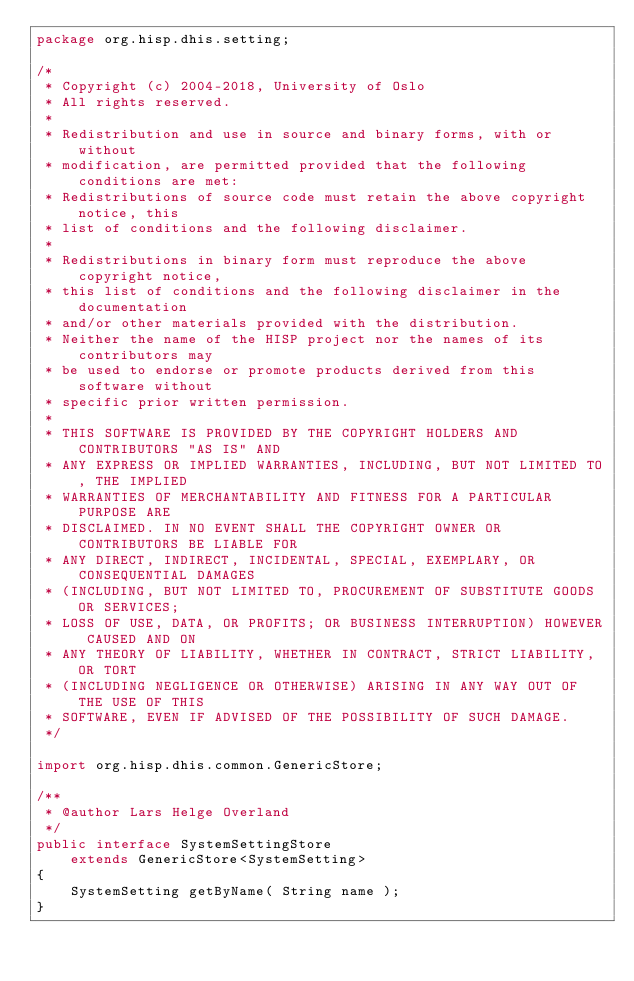<code> <loc_0><loc_0><loc_500><loc_500><_Java_>package org.hisp.dhis.setting;

/*
 * Copyright (c) 2004-2018, University of Oslo
 * All rights reserved.
 *
 * Redistribution and use in source and binary forms, with or without
 * modification, are permitted provided that the following conditions are met:
 * Redistributions of source code must retain the above copyright notice, this
 * list of conditions and the following disclaimer.
 *
 * Redistributions in binary form must reproduce the above copyright notice,
 * this list of conditions and the following disclaimer in the documentation
 * and/or other materials provided with the distribution.
 * Neither the name of the HISP project nor the names of its contributors may
 * be used to endorse or promote products derived from this software without
 * specific prior written permission.
 *
 * THIS SOFTWARE IS PROVIDED BY THE COPYRIGHT HOLDERS AND CONTRIBUTORS "AS IS" AND
 * ANY EXPRESS OR IMPLIED WARRANTIES, INCLUDING, BUT NOT LIMITED TO, THE IMPLIED
 * WARRANTIES OF MERCHANTABILITY AND FITNESS FOR A PARTICULAR PURPOSE ARE
 * DISCLAIMED. IN NO EVENT SHALL THE COPYRIGHT OWNER OR CONTRIBUTORS BE LIABLE FOR
 * ANY DIRECT, INDIRECT, INCIDENTAL, SPECIAL, EXEMPLARY, OR CONSEQUENTIAL DAMAGES
 * (INCLUDING, BUT NOT LIMITED TO, PROCUREMENT OF SUBSTITUTE GOODS OR SERVICES;
 * LOSS OF USE, DATA, OR PROFITS; OR BUSINESS INTERRUPTION) HOWEVER CAUSED AND ON
 * ANY THEORY OF LIABILITY, WHETHER IN CONTRACT, STRICT LIABILITY, OR TORT
 * (INCLUDING NEGLIGENCE OR OTHERWISE) ARISING IN ANY WAY OUT OF THE USE OF THIS
 * SOFTWARE, EVEN IF ADVISED OF THE POSSIBILITY OF SUCH DAMAGE.
 */

import org.hisp.dhis.common.GenericStore;

/**
 * @author Lars Helge Overland
 */
public interface SystemSettingStore
    extends GenericStore<SystemSetting>
{
    SystemSetting getByName( String name );
}
</code> 